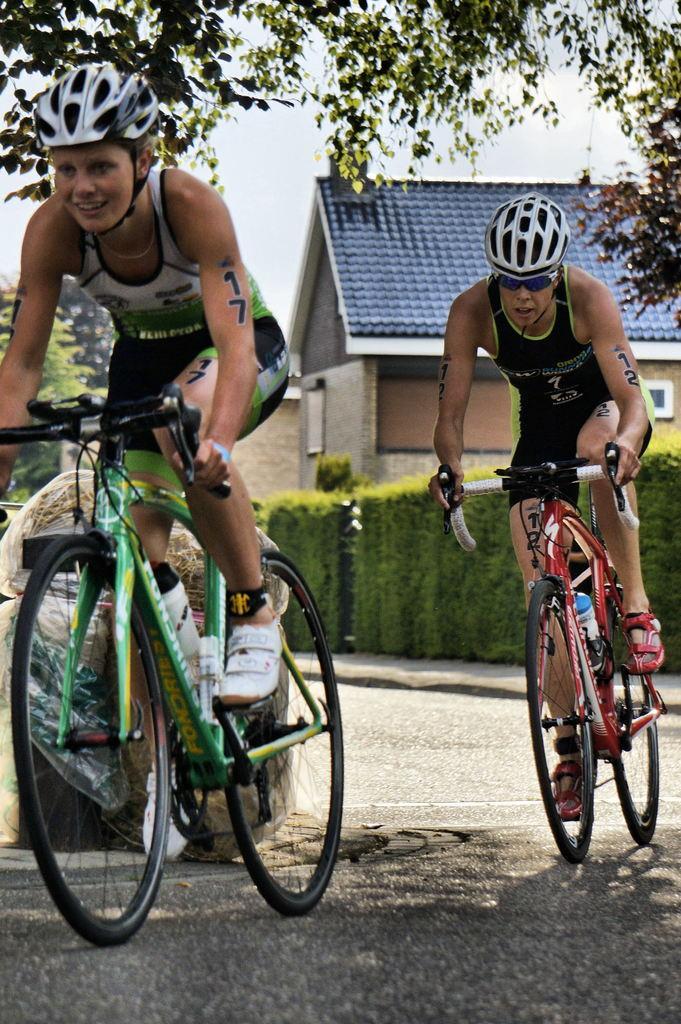Can you describe this image briefly? In this image we can see two people are riding bicycles on the road. In the background, we can see shrubs, wooden houses, trees and the sky. 